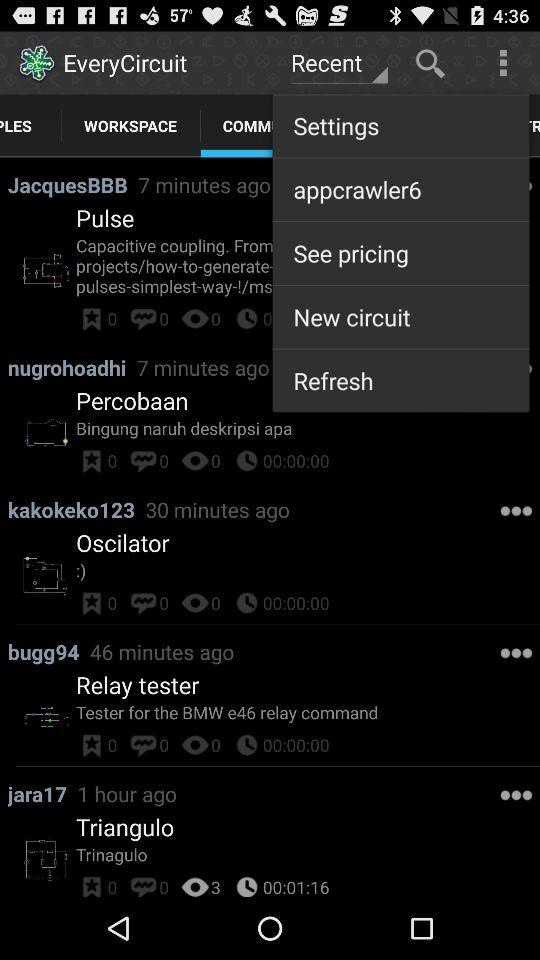What is the time duration of "Triangulo"? The time duration of "Triangulo" is 1 minute 16 seconds. 